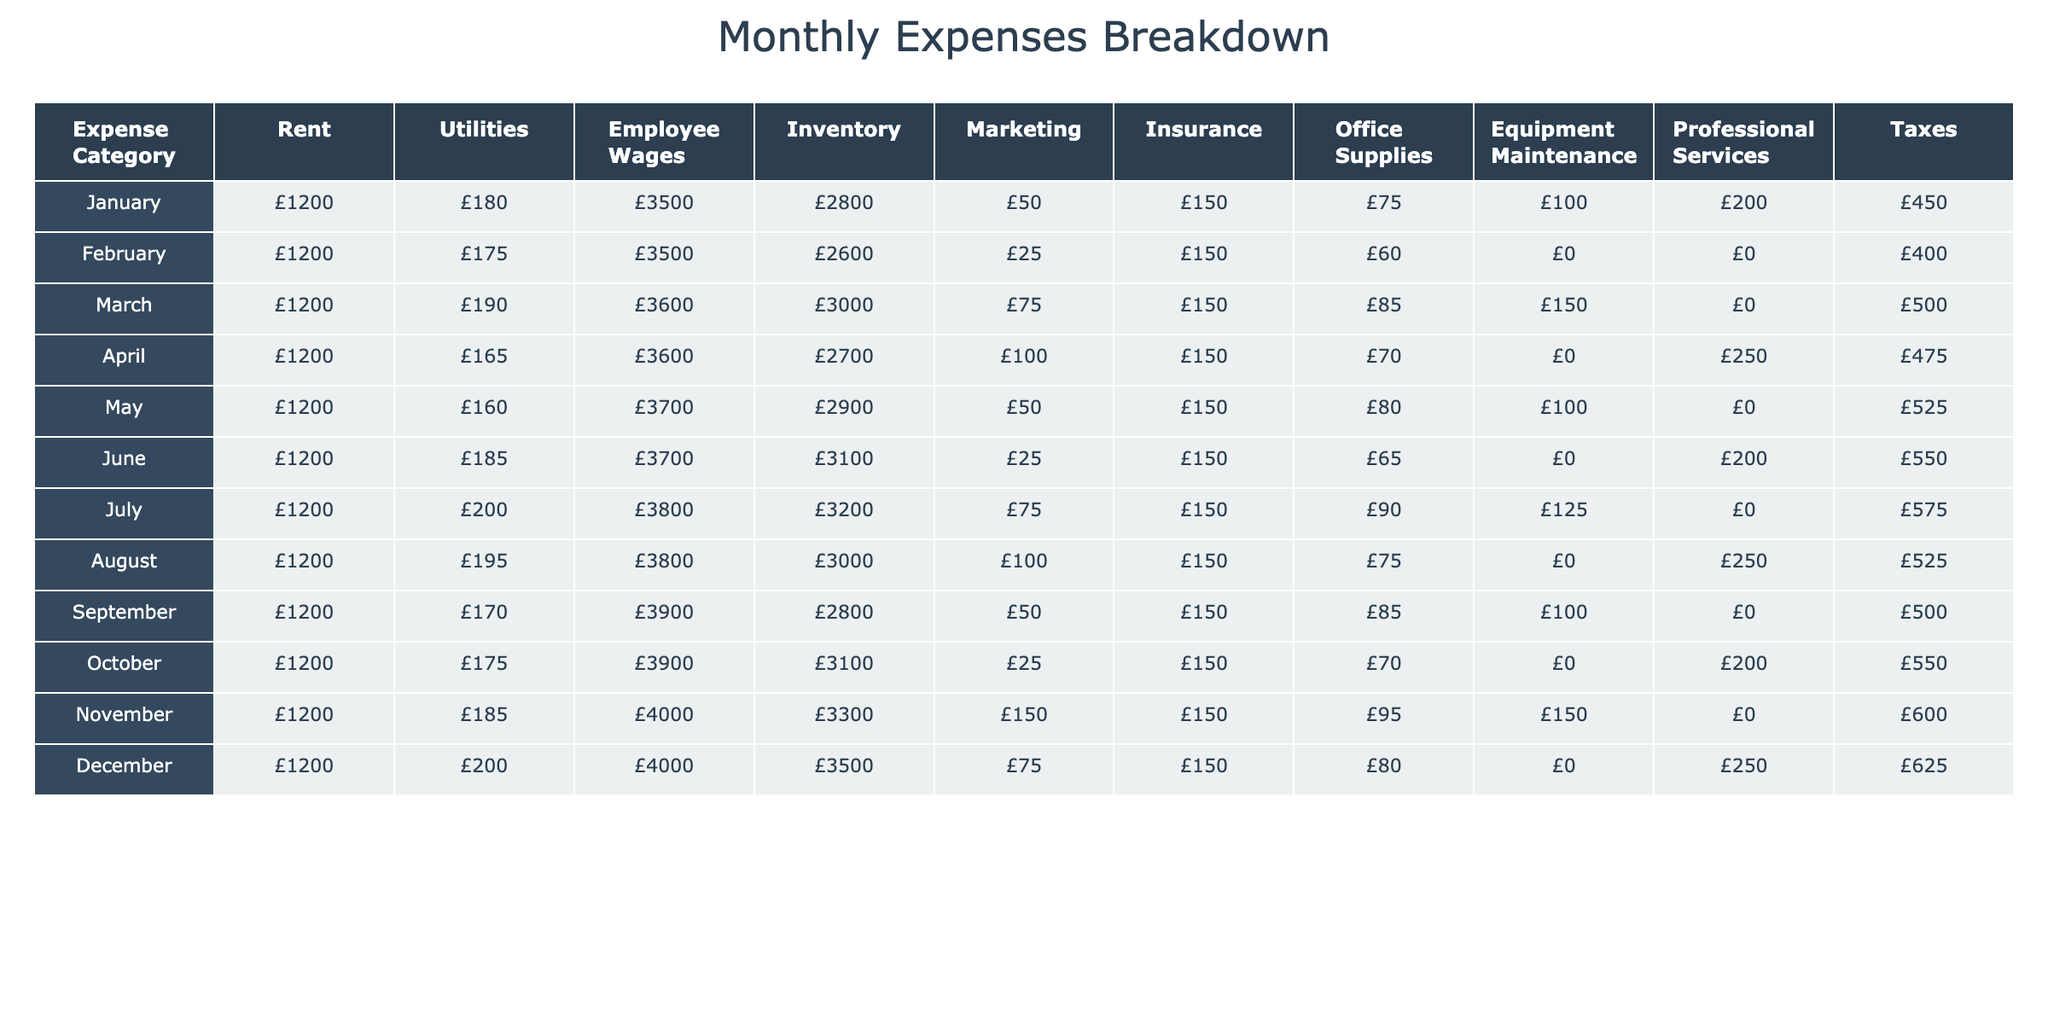What is the total rent expense for the year? We need to add the rent expenses from each month, which is £1200 for each of the 12 months. So, the total rent expense is 12 * £1200 = £14400.
Answer: £14400 In which month did the utilities expense decline the most compared to the previous month? We need to compare each month’s utilities expense with the prior month. The largest decline is from February (£175) to March (£190), which is a decrease of £15.
Answer: February What is the average employee wages expense over the 12 months? To find the average, first sum up the employee wages: £3500 + £3500 + £3600 + £3600 + £3700 + £3700 + £3800 + £3800 + £3900 + £3900 + £4000 + £4000 = £44600. Then, divide by 12: £44600 / 12 = £3716.67.
Answer: £3716.67 Did any month have no marketing expense? We can check each month’s marketing expense and see that February shows a marketing expense of £25, which is non-zero. Therefore, there is no month with zero marketing expense.
Answer: No What was the total inventory expense for the first half of the year? We will sum the inventory expenses from January to June: £2800 + £2600 + £3000 + £2700 + £2900 + £3100 = £17400.
Answer: £17400 Which month had the highest insurance expense, and what was the amount? We can look through the insurance expenses for each month and find the maximum value; all months have £150, indicating that they are equal in this category.
Answer: £150 What is the increase in tax expense from September to October? We need to calculate the difference between October’s (£550) and September’s (£500) tax expenses: £550 - £500 = £50.
Answer: £50 Identify the month with the lowest office supplies expense, and specify the amount. Reviewing the office supplies expenses, the lowest value appears in February (£60).
Answer: £60 What are the total expenses for December? Total expenses for December are calculated as: £1200 (Rent) + £200 (Utilities) + £4000 (Employee Wages) + £3500 (Inventory) + £75 (Marketing) + £150 (Insurance) + £80 (Office Supplies) + £0 (Equipment Maintenance) + £250 (Professional Services) + £625 (Taxes) = £6990.
Answer: £6990 Which category had the most consistent expenditure throughout the year? By analyzing the data, the rent expense shows a steady £1200 every month, suggesting consistency.
Answer: Rent 